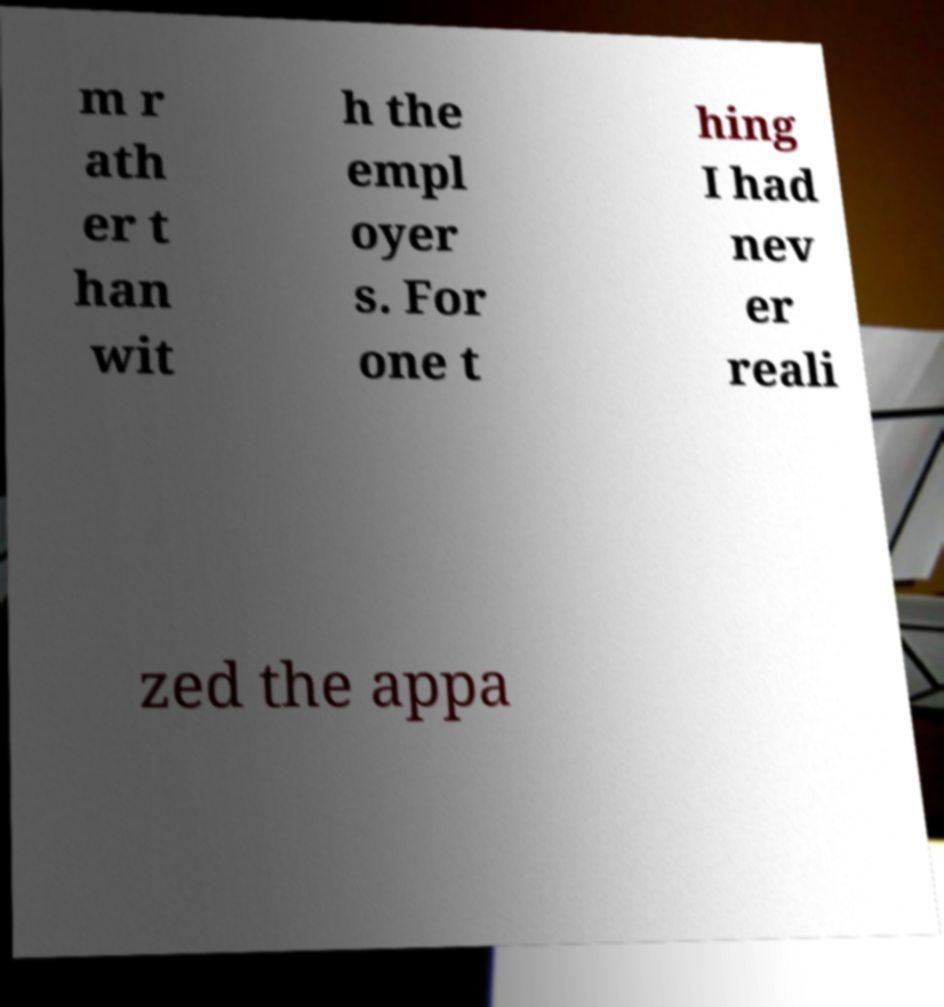I need the written content from this picture converted into text. Can you do that? m r ath er t han wit h the empl oyer s. For one t hing I had nev er reali zed the appa 